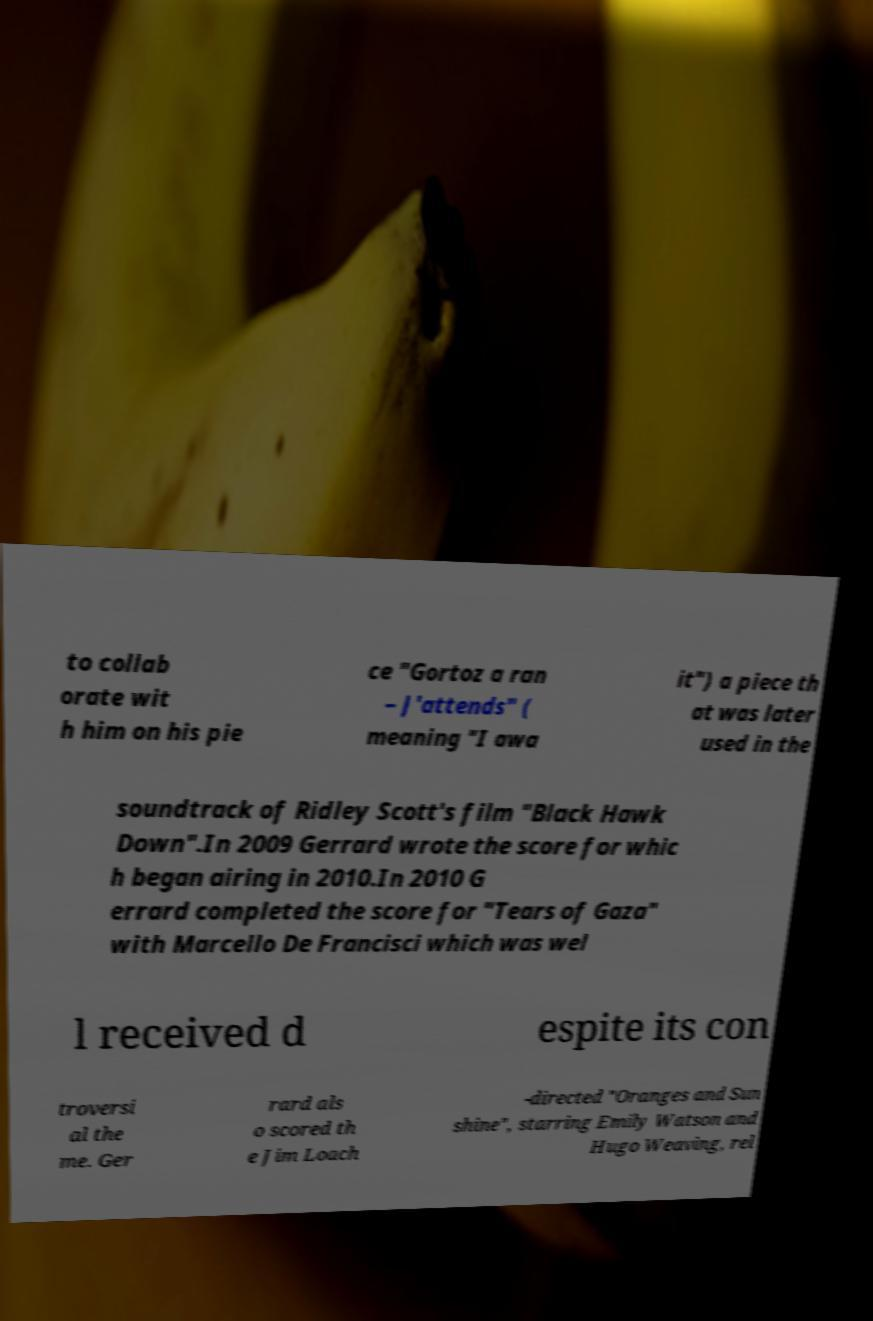Please read and relay the text visible in this image. What does it say? to collab orate wit h him on his pie ce "Gortoz a ran – J'attends" ( meaning "I awa it") a piece th at was later used in the soundtrack of Ridley Scott's film "Black Hawk Down".In 2009 Gerrard wrote the score for whic h began airing in 2010.In 2010 G errard completed the score for "Tears of Gaza" with Marcello De Francisci which was wel l received d espite its con troversi al the me. Ger rard als o scored th e Jim Loach -directed "Oranges and Sun shine", starring Emily Watson and Hugo Weaving, rel 